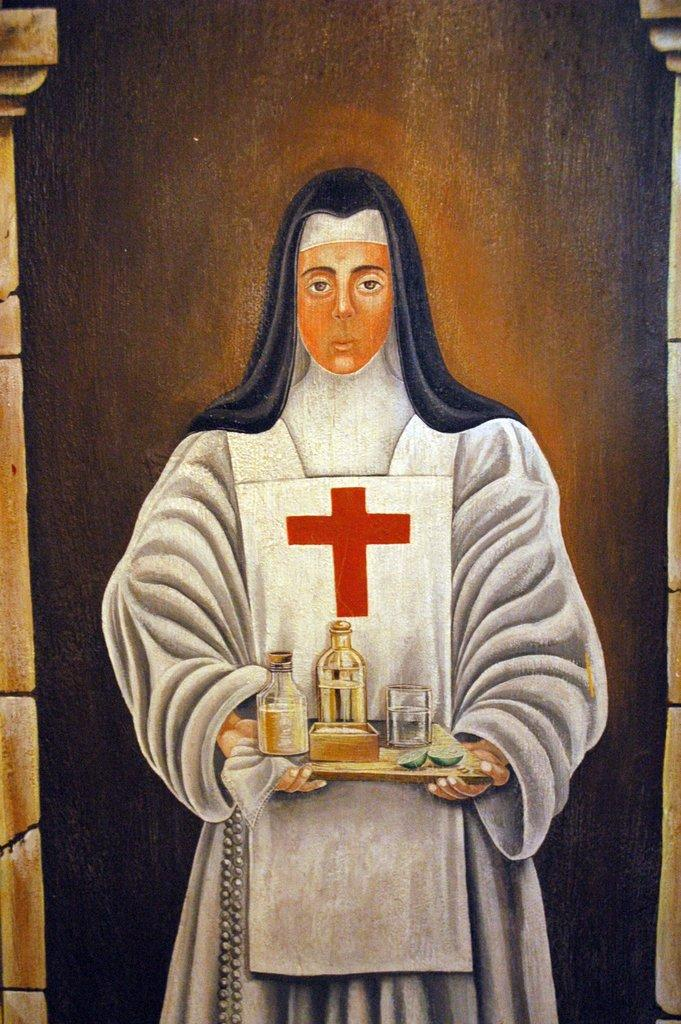What is the main subject of the painting in the image? The painting depicts a nun. What is the nun holding in the painting? The nun is holding a tray. What items can be seen on the tray in the painting? The tray contains bottles, a glass, and other things. What type of wool is used to make the house in the image? There is no house present in the image, and therefore no wool can be associated with it. 